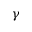<formula> <loc_0><loc_0><loc_500><loc_500>\gamma</formula> 